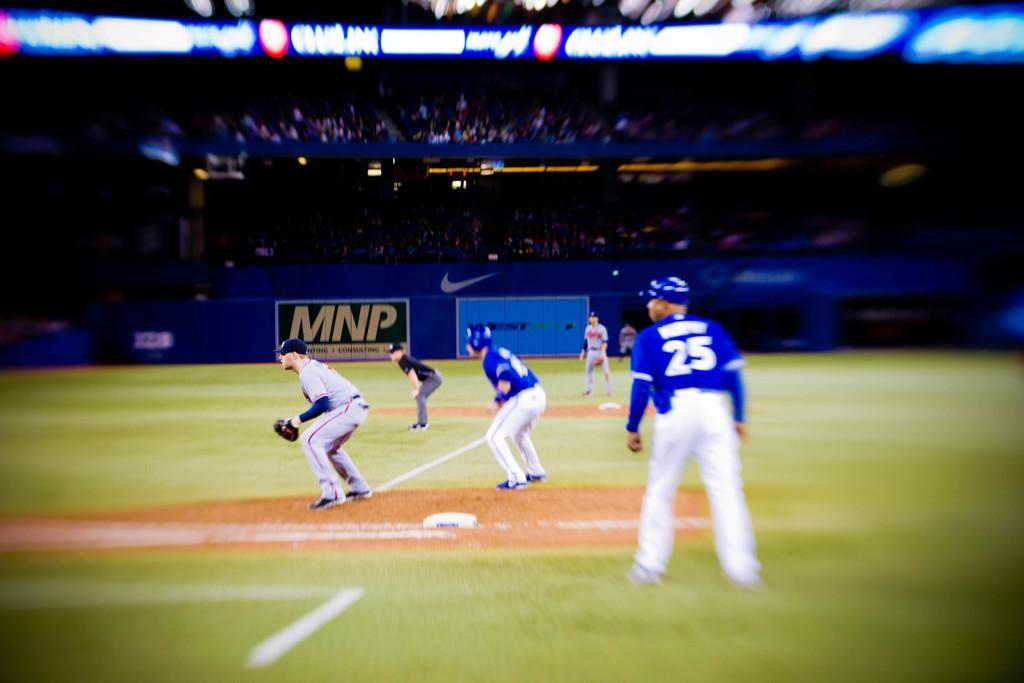<image>
Describe the image concisely. The first base coach who wears number 25 watches the action during a baseball game. 